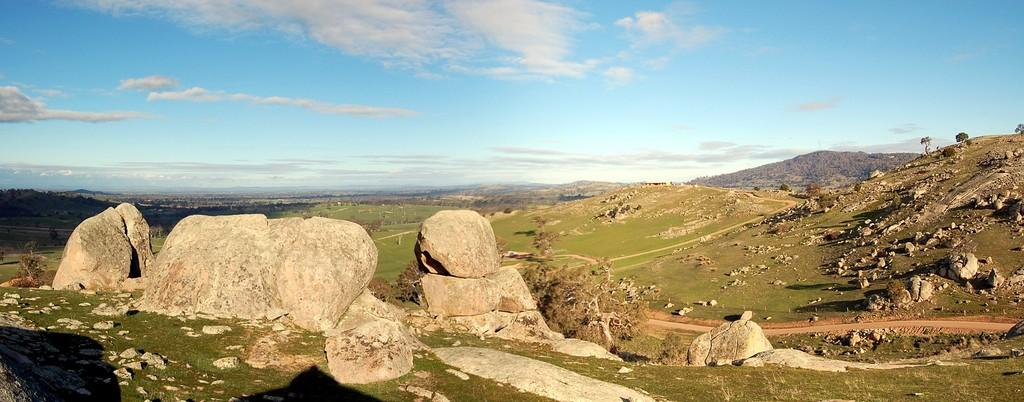What type of landscape is depicted in the image? The image features hills, rocks, and trees, indicating a natural landscape. Can you describe the ground visible in the image? There is ground visible at the bottom of the image. What is visible in the sky at the top of the image? There are clouds in the sky at the top of the image. What type of polish is being applied to the boys' shoes in the image? There are no boys or shoes present in the image; it features a natural landscape with hills, rocks, trees, clouds, and ground. 